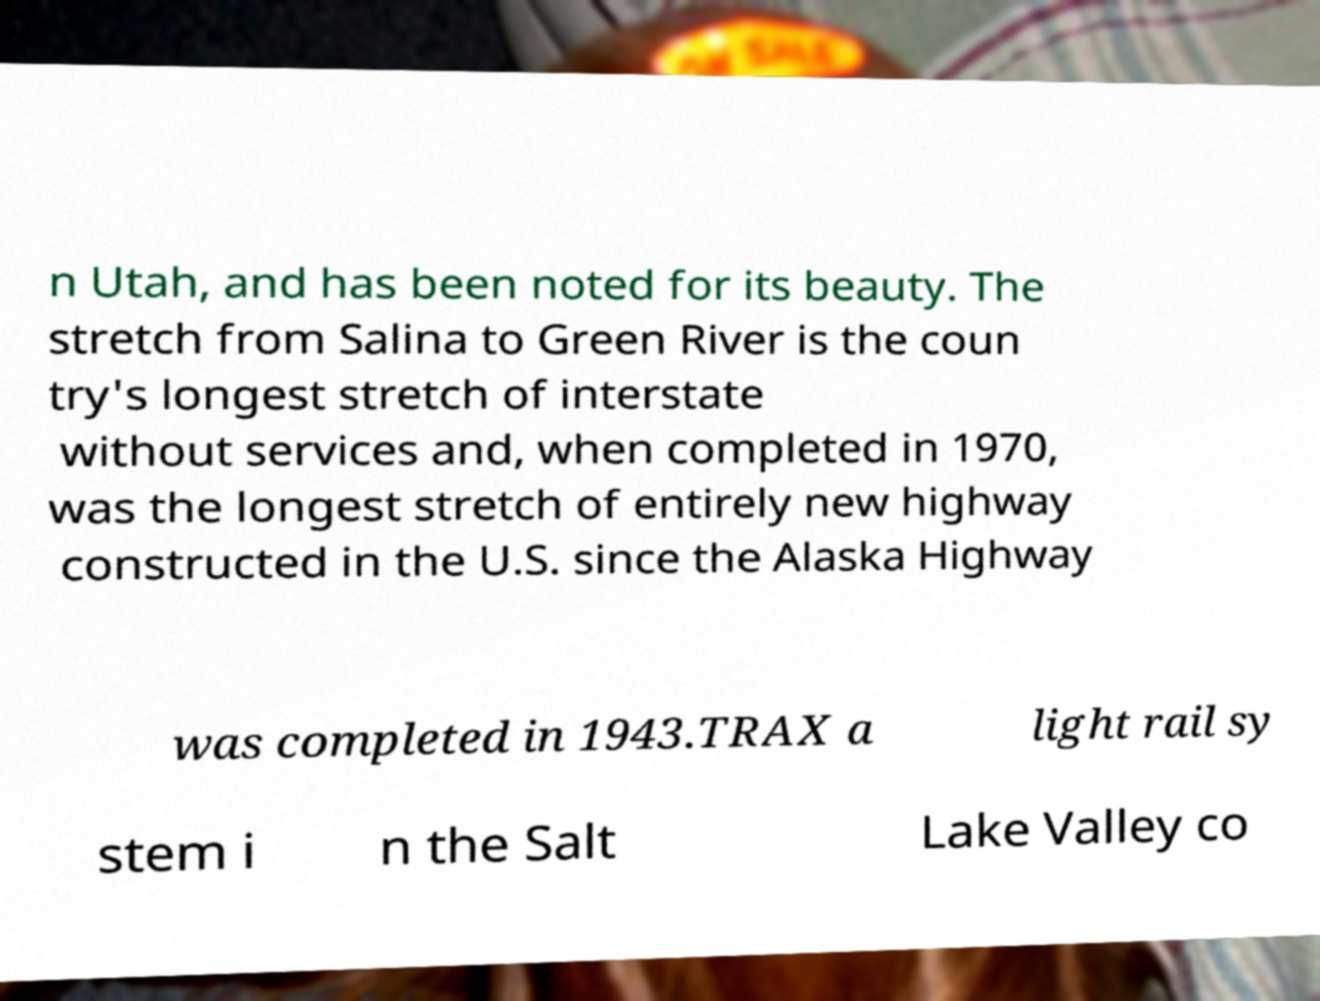Please identify and transcribe the text found in this image. n Utah, and has been noted for its beauty. The stretch from Salina to Green River is the coun try's longest stretch of interstate without services and, when completed in 1970, was the longest stretch of entirely new highway constructed in the U.S. since the Alaska Highway was completed in 1943.TRAX a light rail sy stem i n the Salt Lake Valley co 